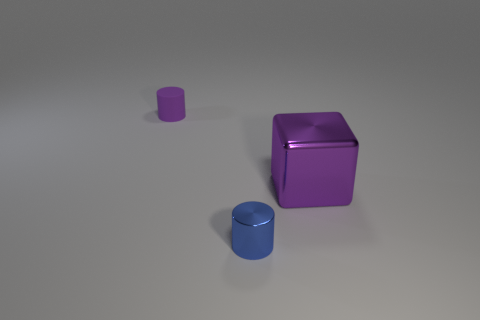Add 1 large gray rubber things. How many objects exist? 4 Subtract all cubes. How many objects are left? 2 Add 2 big metallic things. How many big metallic things are left? 3 Add 2 cubes. How many cubes exist? 3 Subtract 0 cyan balls. How many objects are left? 3 Subtract all red objects. Subtract all cylinders. How many objects are left? 1 